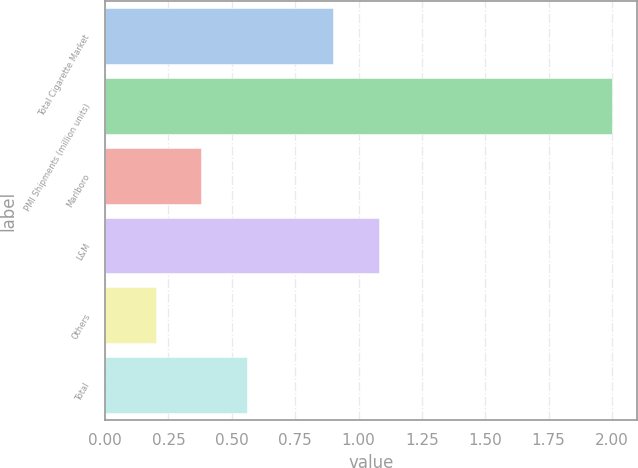Convert chart. <chart><loc_0><loc_0><loc_500><loc_500><bar_chart><fcel>Total Cigarette Market<fcel>PMI Shipments (million units)<fcel>Marlboro<fcel>L&M<fcel>Others<fcel>Total<nl><fcel>0.9<fcel>2<fcel>0.38<fcel>1.08<fcel>0.2<fcel>0.56<nl></chart> 